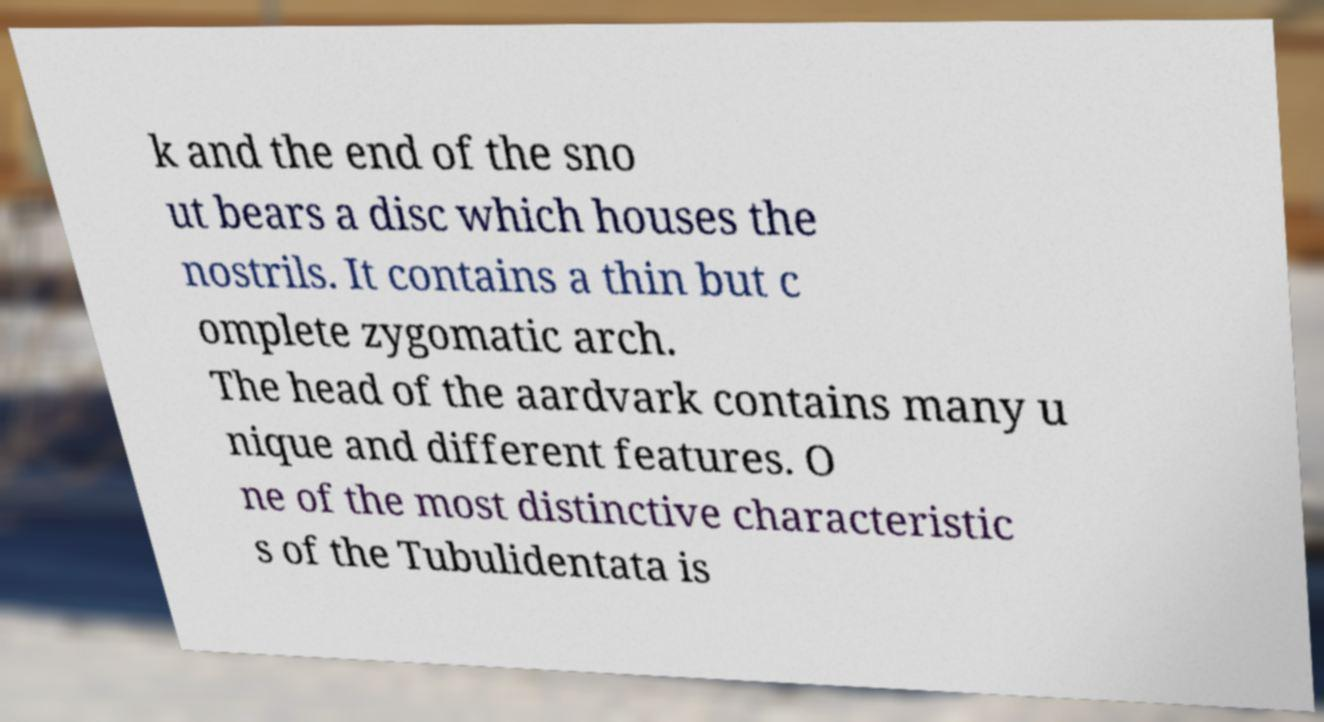Could you extract and type out the text from this image? k and the end of the sno ut bears a disc which houses the nostrils. It contains a thin but c omplete zygomatic arch. The head of the aardvark contains many u nique and different features. O ne of the most distinctive characteristic s of the Tubulidentata is 